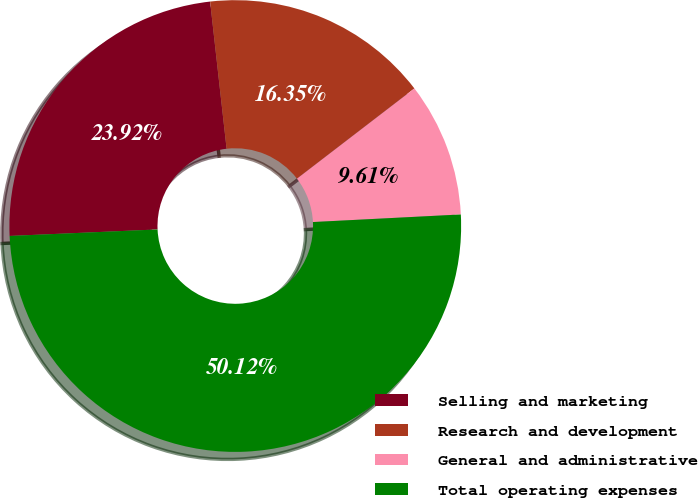<chart> <loc_0><loc_0><loc_500><loc_500><pie_chart><fcel>Selling and marketing<fcel>Research and development<fcel>General and administrative<fcel>Total operating expenses<nl><fcel>23.92%<fcel>16.35%<fcel>9.61%<fcel>50.11%<nl></chart> 